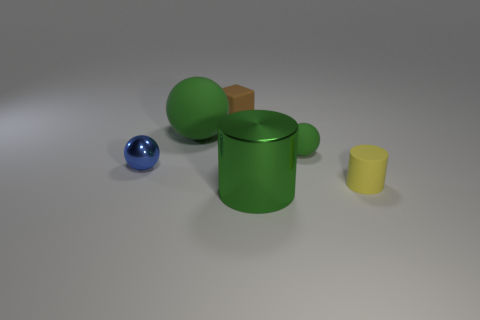The ball that is in front of the green object on the right side of the shiny object right of the block is made of what material? The ball appears to be reflective and exhibits properties consistent with a metallic material, suggesting that it is likely made of metal—which corresponds with common characteristics of metallic surfaces such as high reflectivity and smoothness. 